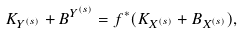Convert formula to latex. <formula><loc_0><loc_0><loc_500><loc_500>K _ { Y ^ { ( s ) } } + B ^ { Y ^ { ( s ) } } = f ^ { * } ( K _ { X ^ { ( s ) } } + B _ { X ^ { ( s ) } } ) ,</formula> 